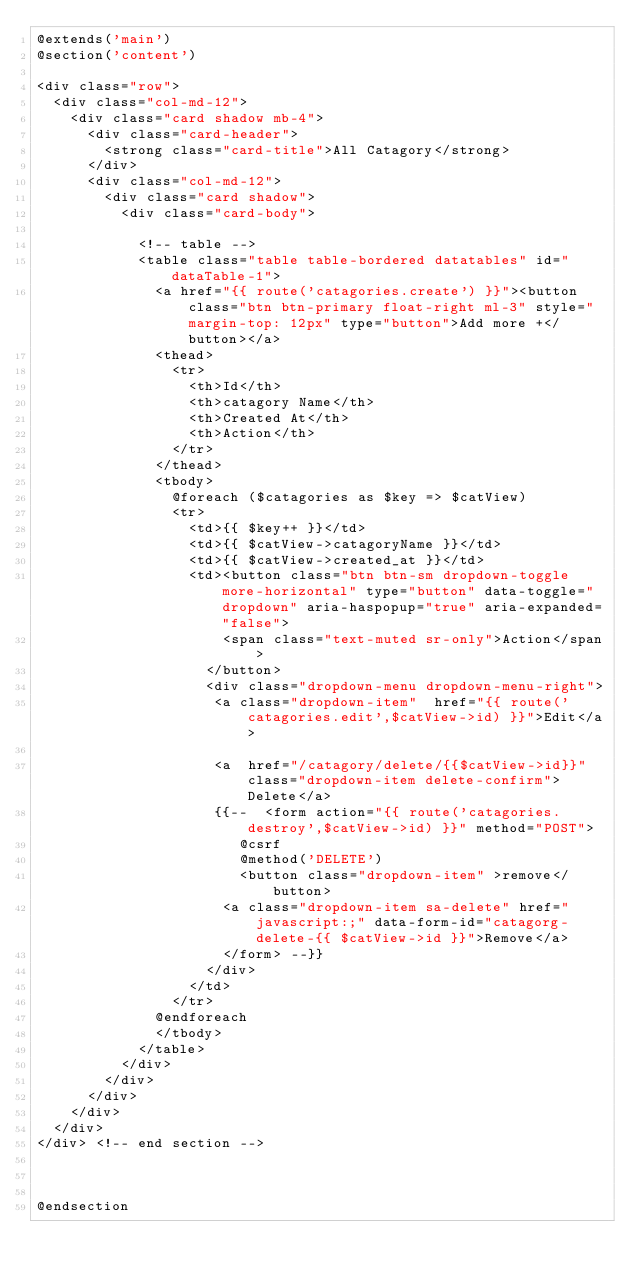Convert code to text. <code><loc_0><loc_0><loc_500><loc_500><_PHP_>@extends('main')
@section('content')

<div class="row">
  <div class="col-md-12">
    <div class="card shadow mb-4">
      <div class="card-header">
        <strong class="card-title">All Catagory</strong>
      </div>
      <div class="col-md-12">
        <div class="card shadow">
          <div class="card-body">
            
            <!-- table -->
            <table class="table table-bordered datatables" id="dataTable-1">
              <a href="{{ route('catagories.create') }}"><button class="btn btn-primary float-right ml-3" style="margin-top: 12px" type="button">Add more +</button></a>
              <thead>    
                <tr>
                  <th>Id</th>
                  <th>catagory Name</th>
                  <th>Created At</th>
                  <th>Action</th>
                </tr>
              </thead>
              <tbody>
                @foreach ($catagories as $key => $catView)
                <tr>      
                  <td>{{ $key++ }}</td>      
                  <td>{{ $catView->catagoryName }}</td>
                  <td>{{ $catView->created_at }}</td>
                  <td><button class="btn btn-sm dropdown-toggle more-horizontal" type="button" data-toggle="dropdown" aria-haspopup="true" aria-expanded="false">
                      <span class="text-muted sr-only">Action</span>
                    </button>
                    <div class="dropdown-menu dropdown-menu-right">
                     <a class="dropdown-item"  href="{{ route('catagories.edit',$catView->id) }}">Edit</a>
          
                     <a  href="/catagory/delete/{{$catView->id}}" class="dropdown-item delete-confirm">Delete</a>
                     {{--  <form action="{{ route('catagories.destroy',$catView->id) }}" method="POST">
                        @csrf
                        @method('DELETE')
                        <button class="dropdown-item" >remove</button>
                      <a class="dropdown-item sa-delete" href="javascript:;" data-form-id="catagorg-delete-{{ $catView->id }}">Remove</a> 
                      </form> --}}
                    </div>
                  </td>
                </tr>
              @endforeach 
              </tbody>
            </table>
          </div>
        </div>
      </div>
    </div>
  </div>
</div> <!-- end section -->

        

@endsection</code> 